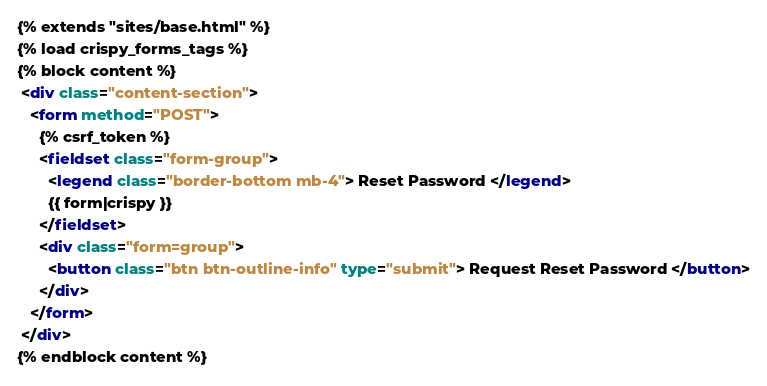<code> <loc_0><loc_0><loc_500><loc_500><_HTML_>{% extends "sites/base.html" %}
{% load crispy_forms_tags %}
{% block content %}
 <div class="content-section">
   <form method="POST">
     {% csrf_token %}
     <fieldset class="form-group">
       <legend class="border-bottom mb-4"> Reset Password </legend>
       {{ form|crispy }}
     </fieldset>
     <div class="form=group">
       <button class="btn btn-outline-info" type="submit"> Request Reset Password </button>
     </div>
   </form>
 </div>
{% endblock content %}
</code> 